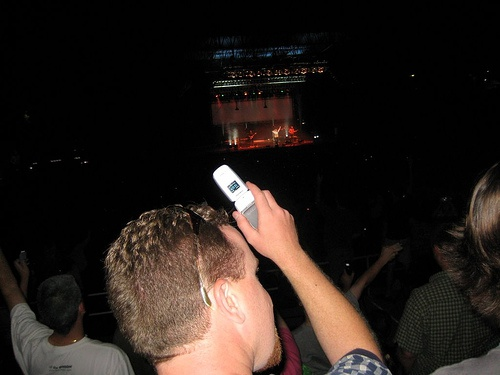Describe the objects in this image and their specific colors. I can see people in black, tan, and gray tones, people in black, gray, and maroon tones, people in black and gray tones, people in black and gray tones, and people in black tones in this image. 